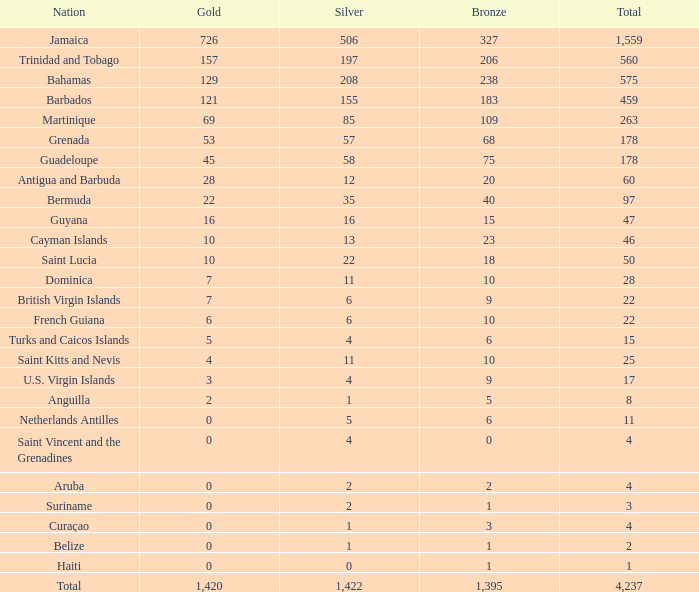What is mentioned as the top silver that also possesses a gold of 4 and a total exceeding 25? None. 